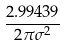Convert formula to latex. <formula><loc_0><loc_0><loc_500><loc_500>\frac { 2 . 9 9 4 3 9 } { 2 \pi \sigma ^ { 2 } }</formula> 